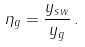Convert formula to latex. <formula><loc_0><loc_0><loc_500><loc_500>\eta _ { g } = \frac { y _ { s w } } { y _ { g } } \, .</formula> 